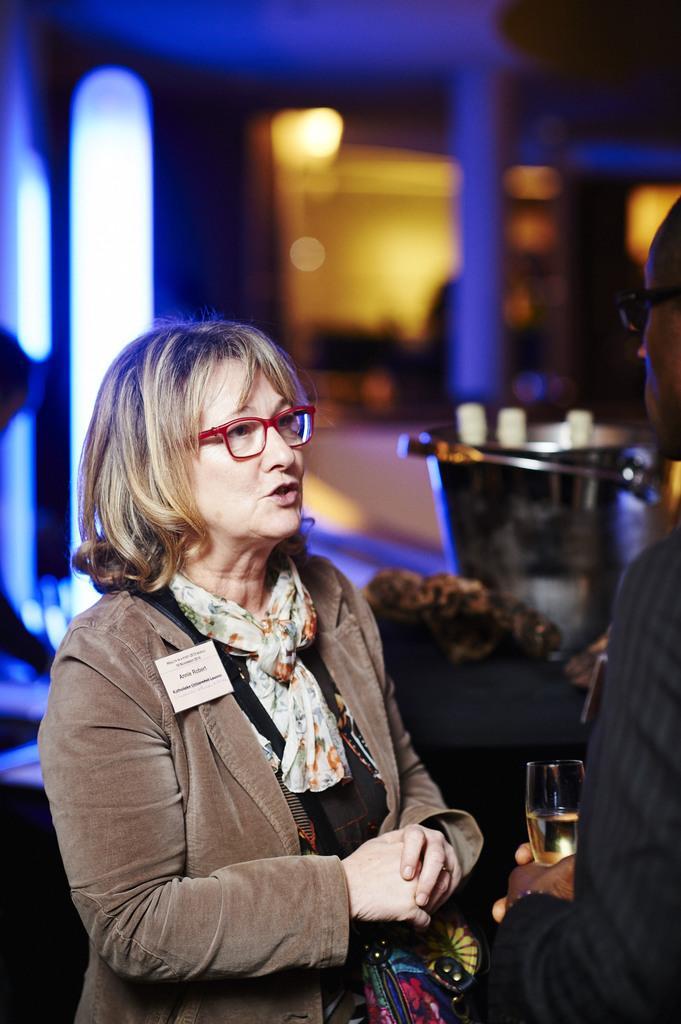How would you summarize this image in a sentence or two? In this image, we can see a woman is talking and wearing bag and glasses. On the right side of the image, we can see a person is holding a wine glass with liquid. Background there is a blur view. Here we can see few objects, things and light. On the left side of the image, we can see human hand and head. 